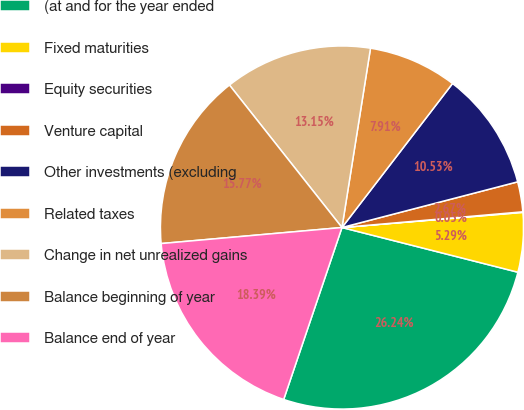<chart> <loc_0><loc_0><loc_500><loc_500><pie_chart><fcel>(at and for the year ended<fcel>Fixed maturities<fcel>Equity securities<fcel>Venture capital<fcel>Other investments (excluding<fcel>Related taxes<fcel>Change in net unrealized gains<fcel>Balance beginning of year<fcel>Balance end of year<nl><fcel>26.24%<fcel>5.29%<fcel>0.05%<fcel>2.67%<fcel>10.53%<fcel>7.91%<fcel>13.15%<fcel>15.77%<fcel>18.39%<nl></chart> 